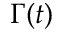<formula> <loc_0><loc_0><loc_500><loc_500>\Gamma ( t )</formula> 